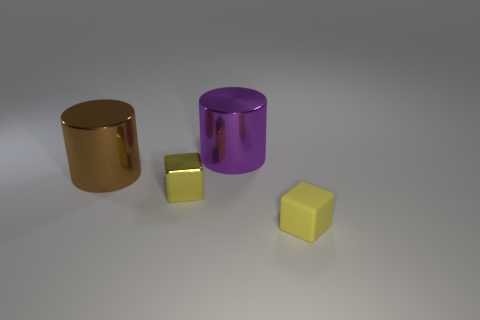Is the small metallic cube the same color as the tiny rubber object?
Give a very brief answer. Yes. Is the shape of the matte thing the same as the brown thing?
Give a very brief answer. No. What size is the yellow shiny block?
Your answer should be very brief. Small. What is the color of the metal object that is both on the left side of the purple cylinder and on the right side of the large brown shiny thing?
Give a very brief answer. Yellow. Is the number of large green rubber cylinders greater than the number of shiny cylinders?
Give a very brief answer. No. How many objects are things or tiny things left of the tiny matte object?
Make the answer very short. 4. Is the size of the brown cylinder the same as the yellow metal cube?
Your response must be concise. No. There is a brown cylinder; are there any large cylinders right of it?
Keep it short and to the point. Yes. How big is the thing that is both on the right side of the tiny metallic thing and to the left of the yellow rubber thing?
Offer a terse response. Large. What number of objects are brown things or tiny cyan blocks?
Your response must be concise. 1. 